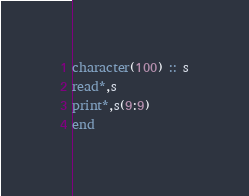<code> <loc_0><loc_0><loc_500><loc_500><_FORTRAN_>character(100) :: s
read*,s
print*,s(9:9)
end</code> 